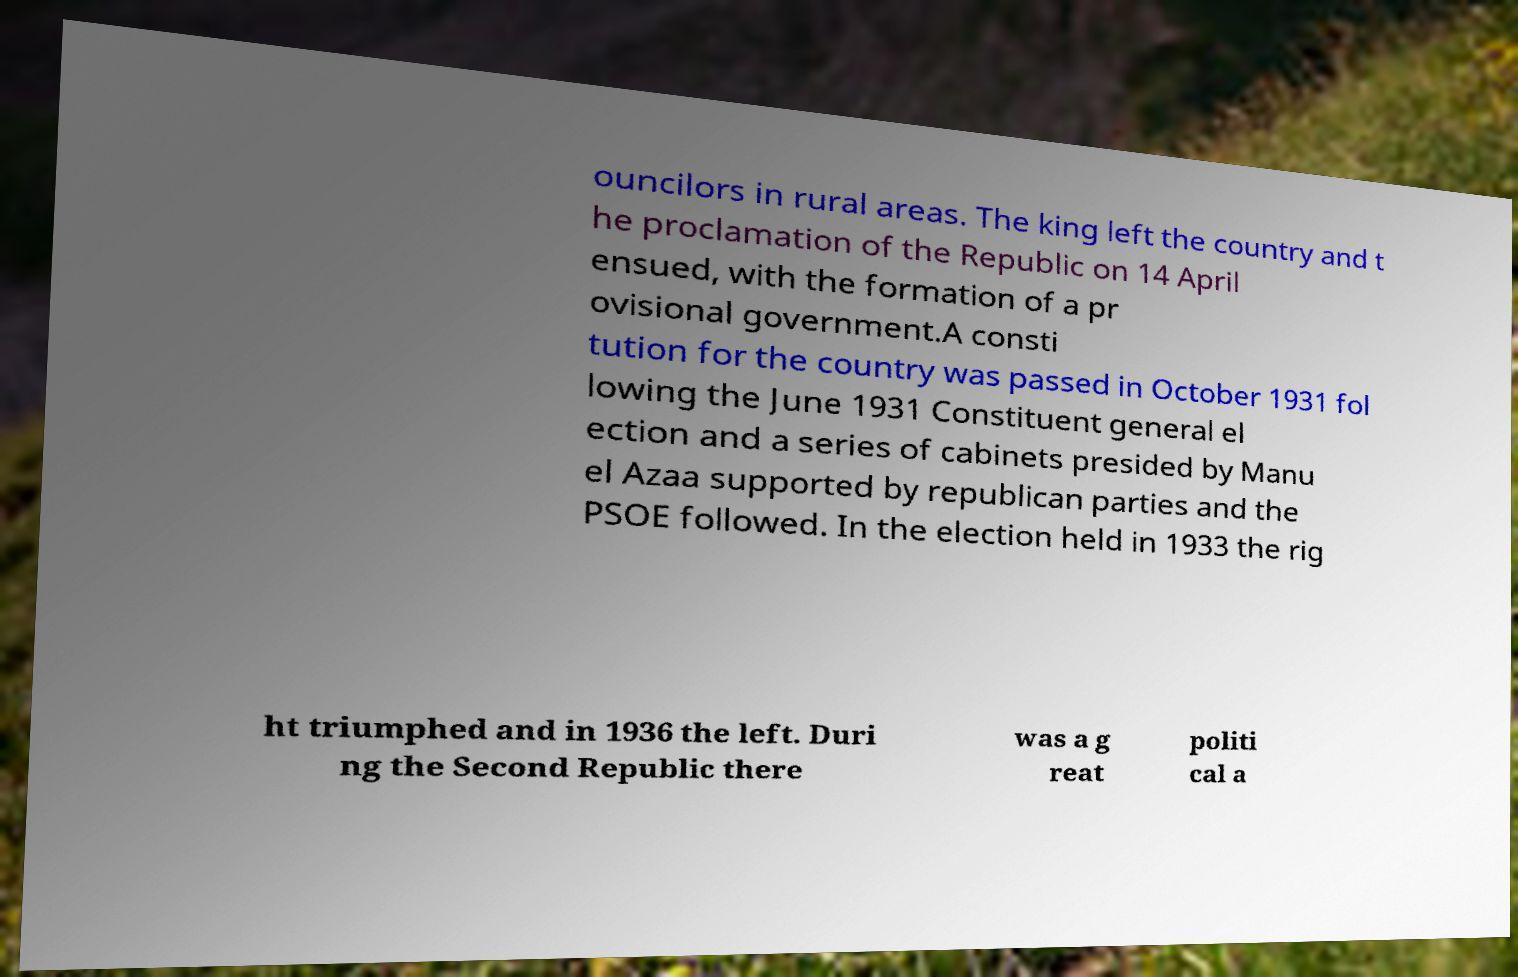Can you read and provide the text displayed in the image?This photo seems to have some interesting text. Can you extract and type it out for me? ouncilors in rural areas. The king left the country and t he proclamation of the Republic on 14 April ensued, with the formation of a pr ovisional government.A consti tution for the country was passed in October 1931 fol lowing the June 1931 Constituent general el ection and a series of cabinets presided by Manu el Azaa supported by republican parties and the PSOE followed. In the election held in 1933 the rig ht triumphed and in 1936 the left. Duri ng the Second Republic there was a g reat politi cal a 